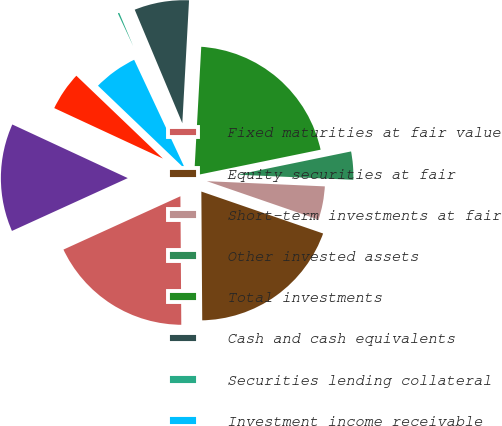Convert chart. <chart><loc_0><loc_0><loc_500><loc_500><pie_chart><fcel>Fixed maturities at fair value<fcel>Equity securities at fair<fcel>Short-term investments at fair<fcel>Other invested assets<fcel>Total investments<fcel>Cash and cash equivalents<fcel>Securities lending collateral<fcel>Investment income receivable<fcel>Finance receivable<fcel>Premiums receivable<nl><fcel>18.3%<fcel>19.61%<fcel>4.58%<fcel>3.92%<fcel>20.91%<fcel>7.19%<fcel>0.65%<fcel>5.88%<fcel>5.23%<fcel>13.73%<nl></chart> 